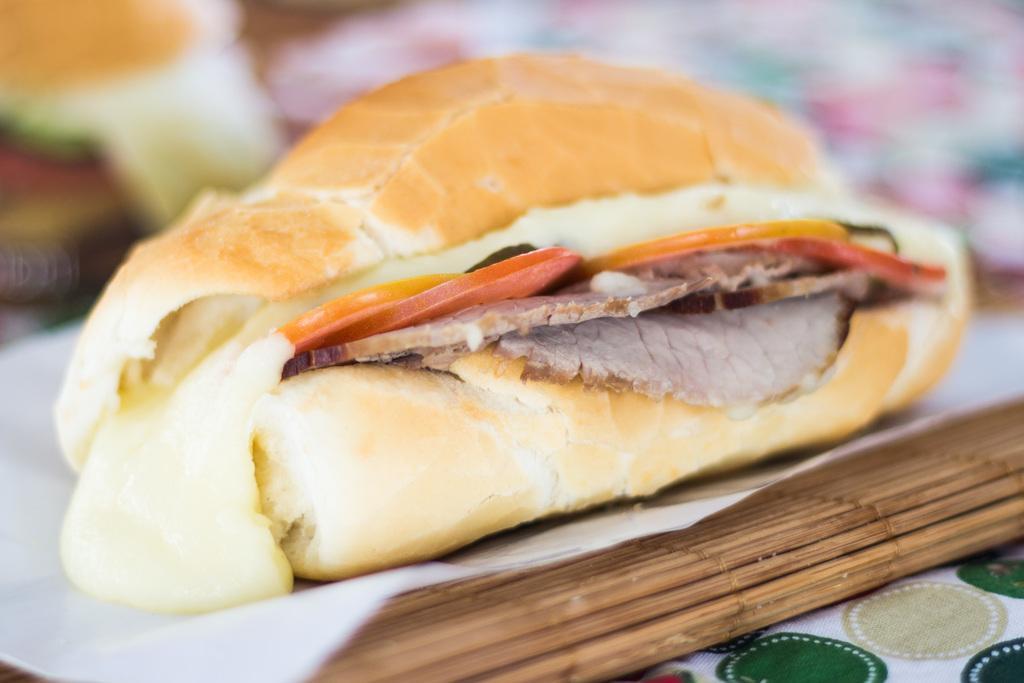Please provide a concise description of this image. In this image we can see a food item which is on the tissue paper. 